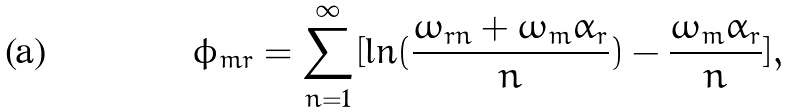Convert formula to latex. <formula><loc_0><loc_0><loc_500><loc_500>\phi _ { m r } = \sum _ { n = 1 } ^ { \infty } [ \ln ( \frac { \omega _ { r n } + \omega _ { m } \alpha _ { r } } { n } ) - \frac { \omega _ { m } \alpha _ { r } } { n } ] ,</formula> 